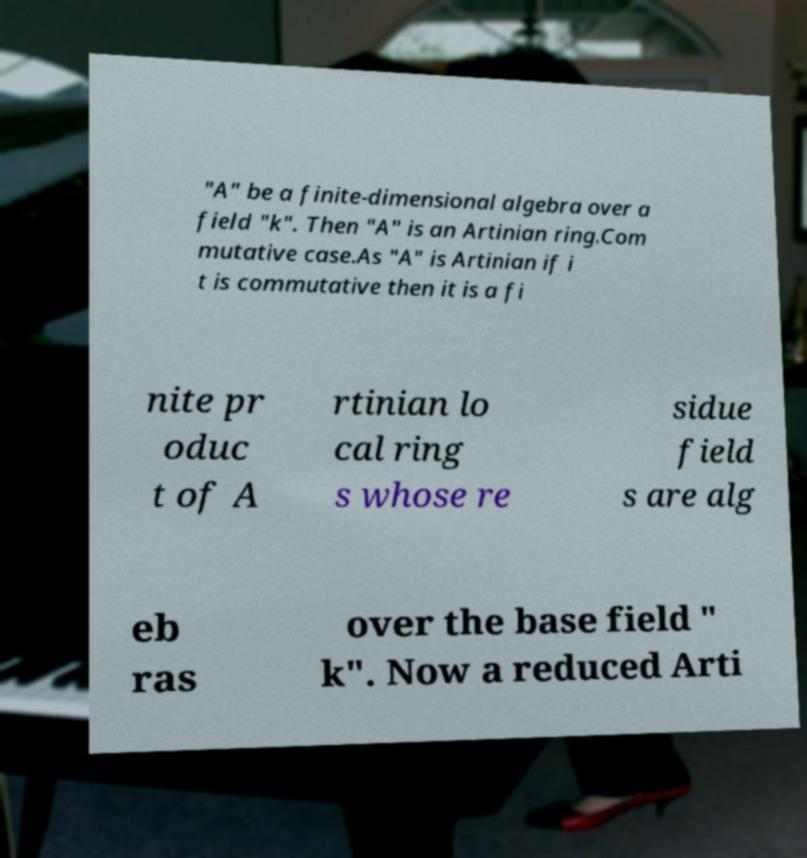Can you read and provide the text displayed in the image?This photo seems to have some interesting text. Can you extract and type it out for me? "A" be a finite-dimensional algebra over a field "k". Then "A" is an Artinian ring.Com mutative case.As "A" is Artinian if i t is commutative then it is a fi nite pr oduc t of A rtinian lo cal ring s whose re sidue field s are alg eb ras over the base field " k". Now a reduced Arti 